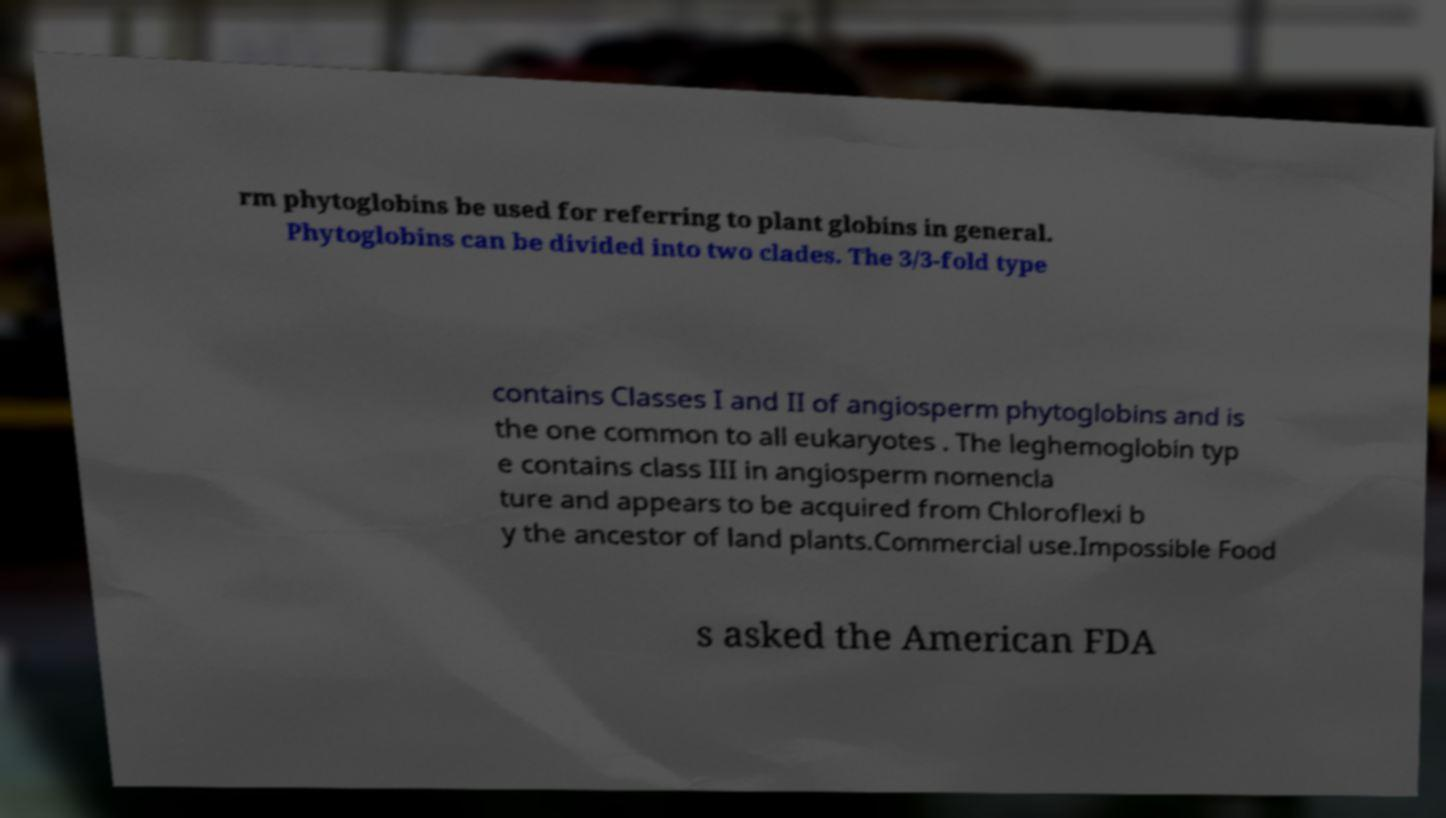Could you assist in decoding the text presented in this image and type it out clearly? rm phytoglobins be used for referring to plant globins in general. Phytoglobins can be divided into two clades. The 3/3-fold type contains Classes I and II of angiosperm phytoglobins and is the one common to all eukaryotes . The leghemoglobin typ e contains class III in angiosperm nomencla ture and appears to be acquired from Chloroflexi b y the ancestor of land plants.Commercial use.Impossible Food s asked the American FDA 